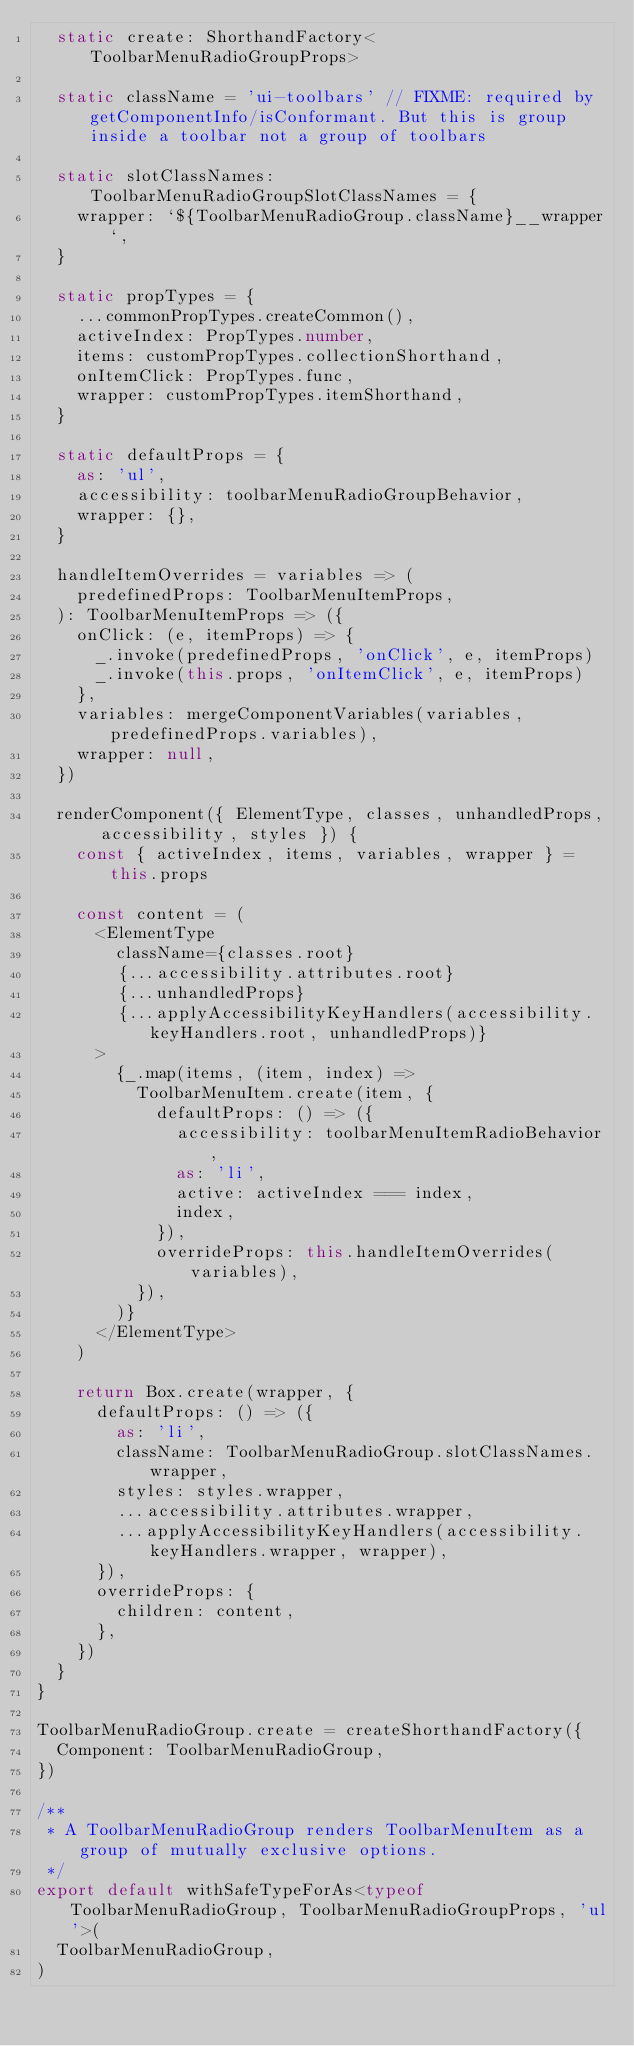<code> <loc_0><loc_0><loc_500><loc_500><_TypeScript_>  static create: ShorthandFactory<ToolbarMenuRadioGroupProps>

  static className = 'ui-toolbars' // FIXME: required by getComponentInfo/isConformant. But this is group inside a toolbar not a group of toolbars

  static slotClassNames: ToolbarMenuRadioGroupSlotClassNames = {
    wrapper: `${ToolbarMenuRadioGroup.className}__wrapper`,
  }

  static propTypes = {
    ...commonPropTypes.createCommon(),
    activeIndex: PropTypes.number,
    items: customPropTypes.collectionShorthand,
    onItemClick: PropTypes.func,
    wrapper: customPropTypes.itemShorthand,
  }

  static defaultProps = {
    as: 'ul',
    accessibility: toolbarMenuRadioGroupBehavior,
    wrapper: {},
  }

  handleItemOverrides = variables => (
    predefinedProps: ToolbarMenuItemProps,
  ): ToolbarMenuItemProps => ({
    onClick: (e, itemProps) => {
      _.invoke(predefinedProps, 'onClick', e, itemProps)
      _.invoke(this.props, 'onItemClick', e, itemProps)
    },
    variables: mergeComponentVariables(variables, predefinedProps.variables),
    wrapper: null,
  })

  renderComponent({ ElementType, classes, unhandledProps, accessibility, styles }) {
    const { activeIndex, items, variables, wrapper } = this.props

    const content = (
      <ElementType
        className={classes.root}
        {...accessibility.attributes.root}
        {...unhandledProps}
        {...applyAccessibilityKeyHandlers(accessibility.keyHandlers.root, unhandledProps)}
      >
        {_.map(items, (item, index) =>
          ToolbarMenuItem.create(item, {
            defaultProps: () => ({
              accessibility: toolbarMenuItemRadioBehavior,
              as: 'li',
              active: activeIndex === index,
              index,
            }),
            overrideProps: this.handleItemOverrides(variables),
          }),
        )}
      </ElementType>
    )

    return Box.create(wrapper, {
      defaultProps: () => ({
        as: 'li',
        className: ToolbarMenuRadioGroup.slotClassNames.wrapper,
        styles: styles.wrapper,
        ...accessibility.attributes.wrapper,
        ...applyAccessibilityKeyHandlers(accessibility.keyHandlers.wrapper, wrapper),
      }),
      overrideProps: {
        children: content,
      },
    })
  }
}

ToolbarMenuRadioGroup.create = createShorthandFactory({
  Component: ToolbarMenuRadioGroup,
})

/**
 * A ToolbarMenuRadioGroup renders ToolbarMenuItem as a group of mutually exclusive options.
 */
export default withSafeTypeForAs<typeof ToolbarMenuRadioGroup, ToolbarMenuRadioGroupProps, 'ul'>(
  ToolbarMenuRadioGroup,
)
</code> 